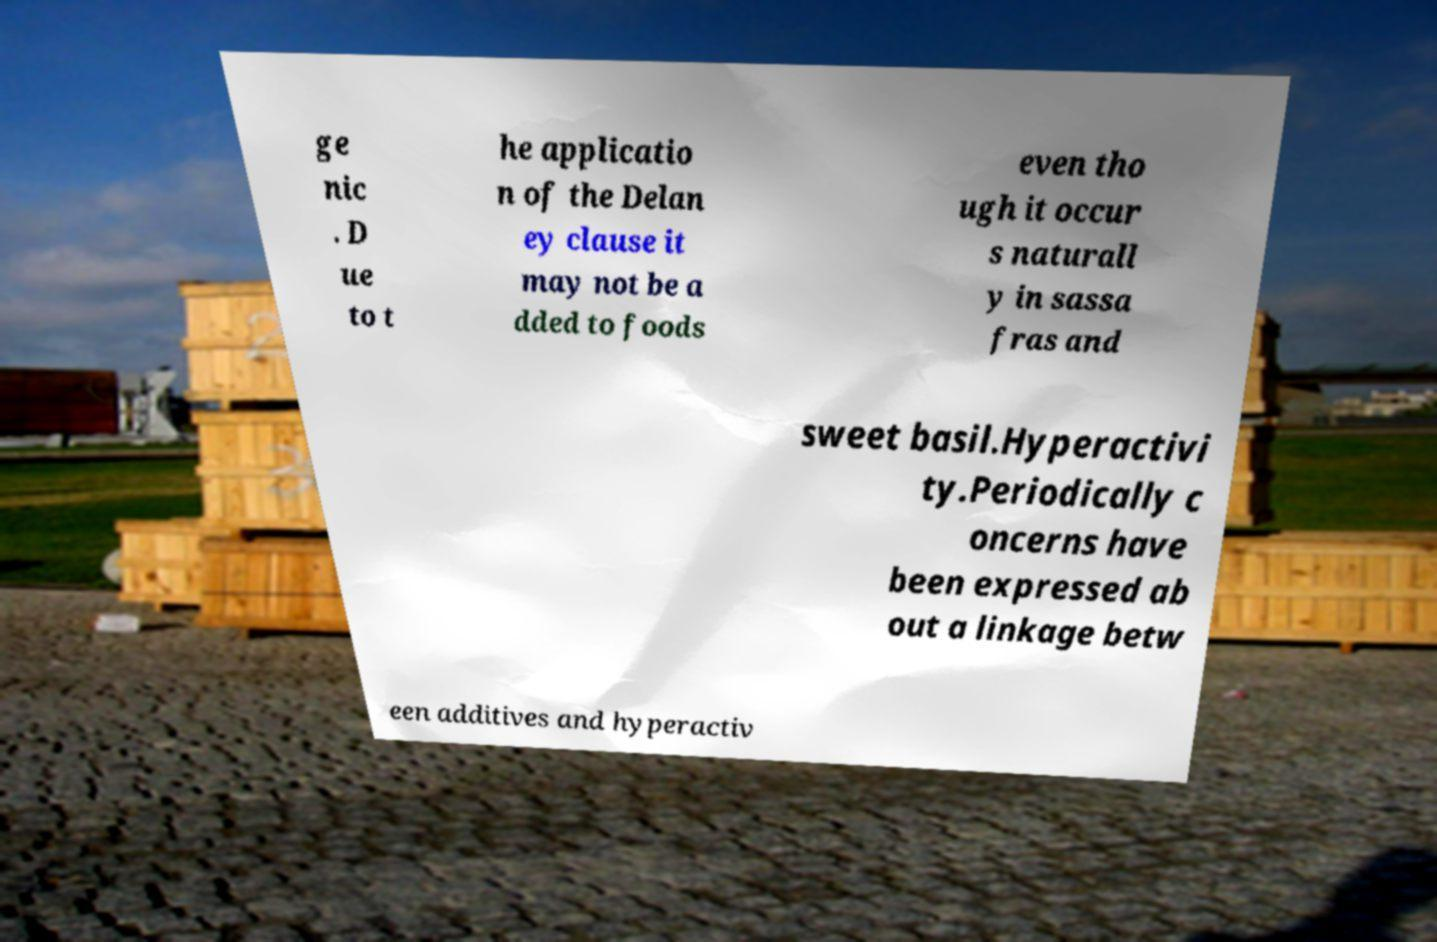Please read and relay the text visible in this image. What does it say? ge nic . D ue to t he applicatio n of the Delan ey clause it may not be a dded to foods even tho ugh it occur s naturall y in sassa fras and sweet basil.Hyperactivi ty.Periodically c oncerns have been expressed ab out a linkage betw een additives and hyperactiv 